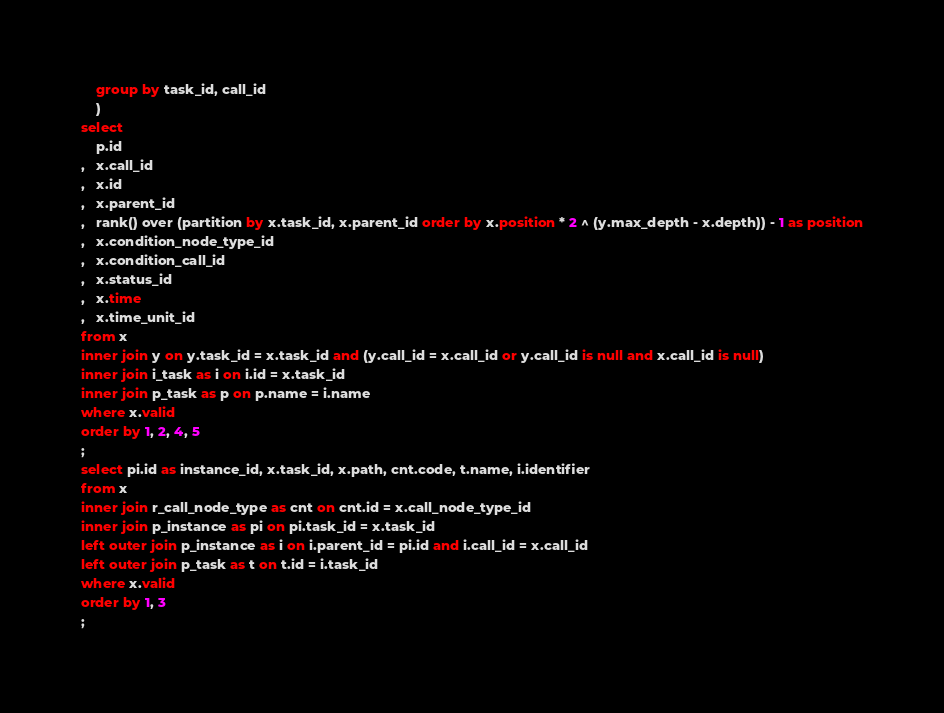<code> <loc_0><loc_0><loc_500><loc_500><_SQL_>    group by task_id, call_id
    )
select
    p.id
,   x.call_id
,   x.id
,   x.parent_id
,   rank() over (partition by x.task_id, x.parent_id order by x.position * 2 ^ (y.max_depth - x.depth)) - 1 as position
,   x.condition_node_type_id
,   x.condition_call_id
,   x.status_id
,   x.time
,   x.time_unit_id
from x
inner join y on y.task_id = x.task_id and (y.call_id = x.call_id or y.call_id is null and x.call_id is null)
inner join i_task as i on i.id = x.task_id
inner join p_task as p on p.name = i.name
where x.valid
order by 1, 2, 4, 5
;
select pi.id as instance_id, x.task_id, x.path, cnt.code, t.name, i.identifier
from x
inner join r_call_node_type as cnt on cnt.id = x.call_node_type_id
inner join p_instance as pi on pi.task_id = x.task_id
left outer join p_instance as i on i.parent_id = pi.id and i.call_id = x.call_id
left outer join p_task as t on t.id = i.task_id
where x.valid
order by 1, 3
;

</code> 